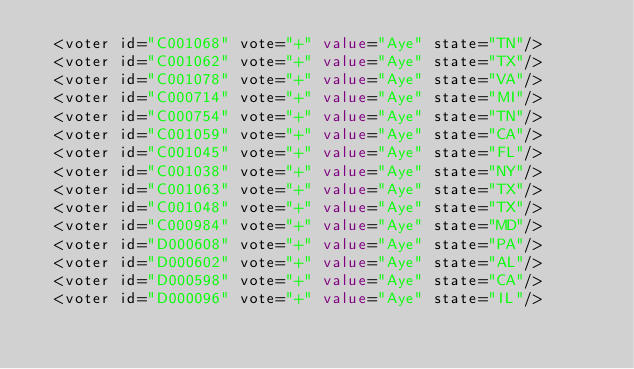Convert code to text. <code><loc_0><loc_0><loc_500><loc_500><_XML_>  <voter id="C001068" vote="+" value="Aye" state="TN"/>
  <voter id="C001062" vote="+" value="Aye" state="TX"/>
  <voter id="C001078" vote="+" value="Aye" state="VA"/>
  <voter id="C000714" vote="+" value="Aye" state="MI"/>
  <voter id="C000754" vote="+" value="Aye" state="TN"/>
  <voter id="C001059" vote="+" value="Aye" state="CA"/>
  <voter id="C001045" vote="+" value="Aye" state="FL"/>
  <voter id="C001038" vote="+" value="Aye" state="NY"/>
  <voter id="C001063" vote="+" value="Aye" state="TX"/>
  <voter id="C001048" vote="+" value="Aye" state="TX"/>
  <voter id="C000984" vote="+" value="Aye" state="MD"/>
  <voter id="D000608" vote="+" value="Aye" state="PA"/>
  <voter id="D000602" vote="+" value="Aye" state="AL"/>
  <voter id="D000598" vote="+" value="Aye" state="CA"/>
  <voter id="D000096" vote="+" value="Aye" state="IL"/></code> 